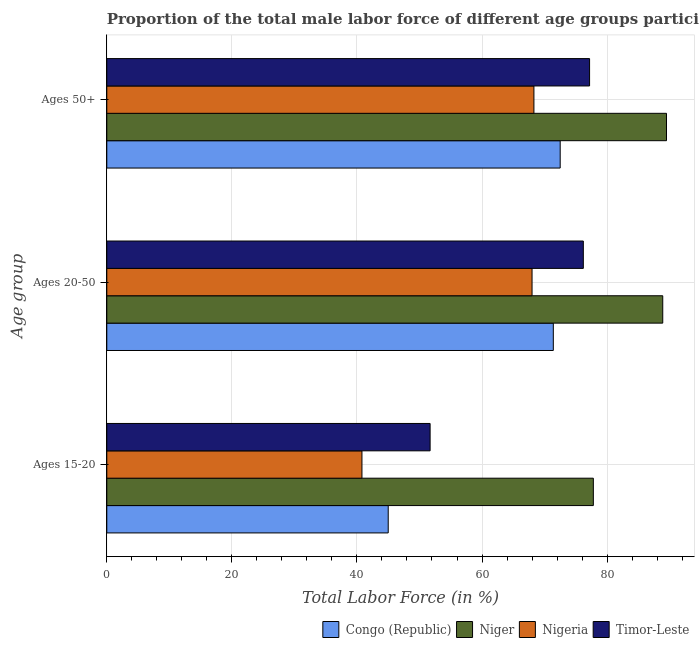How many groups of bars are there?
Your response must be concise. 3. What is the label of the 2nd group of bars from the top?
Offer a terse response. Ages 20-50. What is the percentage of male labor force within the age group 20-50 in Timor-Leste?
Your response must be concise. 76.2. Across all countries, what is the maximum percentage of male labor force above age 50?
Offer a terse response. 89.5. In which country was the percentage of male labor force above age 50 maximum?
Offer a very short reply. Niger. In which country was the percentage of male labor force above age 50 minimum?
Provide a succinct answer. Nigeria. What is the total percentage of male labor force within the age group 15-20 in the graph?
Provide a short and direct response. 215.3. What is the difference between the percentage of male labor force within the age group 20-50 in Niger and that in Nigeria?
Give a very brief answer. 20.9. What is the difference between the percentage of male labor force within the age group 20-50 in Timor-Leste and the percentage of male labor force within the age group 15-20 in Congo (Republic)?
Provide a short and direct response. 31.2. What is the average percentage of male labor force within the age group 15-20 per country?
Your response must be concise. 53.83. What is the difference between the percentage of male labor force above age 50 and percentage of male labor force within the age group 15-20 in Nigeria?
Make the answer very short. 27.5. In how many countries, is the percentage of male labor force within the age group 15-20 greater than 24 %?
Your response must be concise. 4. What is the ratio of the percentage of male labor force within the age group 20-50 in Congo (Republic) to that in Niger?
Make the answer very short. 0.8. Is the percentage of male labor force within the age group 15-20 in Niger less than that in Congo (Republic)?
Offer a very short reply. No. What is the difference between the highest and the second highest percentage of male labor force within the age group 15-20?
Your answer should be compact. 26.1. What is the difference between the highest and the lowest percentage of male labor force within the age group 15-20?
Provide a short and direct response. 37. In how many countries, is the percentage of male labor force within the age group 15-20 greater than the average percentage of male labor force within the age group 15-20 taken over all countries?
Provide a short and direct response. 1. Is the sum of the percentage of male labor force within the age group 15-20 in Timor-Leste and Niger greater than the maximum percentage of male labor force within the age group 20-50 across all countries?
Keep it short and to the point. Yes. What does the 1st bar from the top in Ages 15-20 represents?
Make the answer very short. Timor-Leste. What does the 3rd bar from the bottom in Ages 15-20 represents?
Provide a succinct answer. Nigeria. Is it the case that in every country, the sum of the percentage of male labor force within the age group 15-20 and percentage of male labor force within the age group 20-50 is greater than the percentage of male labor force above age 50?
Your response must be concise. Yes. How many countries are there in the graph?
Provide a succinct answer. 4. What is the difference between two consecutive major ticks on the X-axis?
Offer a terse response. 20. Are the values on the major ticks of X-axis written in scientific E-notation?
Your response must be concise. No. Does the graph contain any zero values?
Ensure brevity in your answer.  No. Does the graph contain grids?
Provide a short and direct response. Yes. How many legend labels are there?
Make the answer very short. 4. What is the title of the graph?
Give a very brief answer. Proportion of the total male labor force of different age groups participating in production in 1999. Does "Puerto Rico" appear as one of the legend labels in the graph?
Your answer should be very brief. No. What is the label or title of the Y-axis?
Your answer should be very brief. Age group. What is the Total Labor Force (in %) in Niger in Ages 15-20?
Keep it short and to the point. 77.8. What is the Total Labor Force (in %) in Nigeria in Ages 15-20?
Make the answer very short. 40.8. What is the Total Labor Force (in %) in Timor-Leste in Ages 15-20?
Your response must be concise. 51.7. What is the Total Labor Force (in %) in Congo (Republic) in Ages 20-50?
Ensure brevity in your answer.  71.4. What is the Total Labor Force (in %) in Niger in Ages 20-50?
Offer a very short reply. 88.9. What is the Total Labor Force (in %) in Timor-Leste in Ages 20-50?
Your response must be concise. 76.2. What is the Total Labor Force (in %) of Congo (Republic) in Ages 50+?
Your answer should be very brief. 72.5. What is the Total Labor Force (in %) of Niger in Ages 50+?
Your answer should be very brief. 89.5. What is the Total Labor Force (in %) of Nigeria in Ages 50+?
Keep it short and to the point. 68.3. What is the Total Labor Force (in %) in Timor-Leste in Ages 50+?
Provide a short and direct response. 77.2. Across all Age group, what is the maximum Total Labor Force (in %) in Congo (Republic)?
Offer a very short reply. 72.5. Across all Age group, what is the maximum Total Labor Force (in %) in Niger?
Keep it short and to the point. 89.5. Across all Age group, what is the maximum Total Labor Force (in %) of Nigeria?
Offer a terse response. 68.3. Across all Age group, what is the maximum Total Labor Force (in %) in Timor-Leste?
Make the answer very short. 77.2. Across all Age group, what is the minimum Total Labor Force (in %) in Niger?
Keep it short and to the point. 77.8. Across all Age group, what is the minimum Total Labor Force (in %) of Nigeria?
Provide a short and direct response. 40.8. Across all Age group, what is the minimum Total Labor Force (in %) of Timor-Leste?
Your answer should be very brief. 51.7. What is the total Total Labor Force (in %) in Congo (Republic) in the graph?
Make the answer very short. 188.9. What is the total Total Labor Force (in %) in Niger in the graph?
Give a very brief answer. 256.2. What is the total Total Labor Force (in %) in Nigeria in the graph?
Provide a succinct answer. 177.1. What is the total Total Labor Force (in %) in Timor-Leste in the graph?
Your answer should be compact. 205.1. What is the difference between the Total Labor Force (in %) of Congo (Republic) in Ages 15-20 and that in Ages 20-50?
Your answer should be very brief. -26.4. What is the difference between the Total Labor Force (in %) of Nigeria in Ages 15-20 and that in Ages 20-50?
Keep it short and to the point. -27.2. What is the difference between the Total Labor Force (in %) of Timor-Leste in Ages 15-20 and that in Ages 20-50?
Make the answer very short. -24.5. What is the difference between the Total Labor Force (in %) in Congo (Republic) in Ages 15-20 and that in Ages 50+?
Provide a short and direct response. -27.5. What is the difference between the Total Labor Force (in %) in Niger in Ages 15-20 and that in Ages 50+?
Offer a very short reply. -11.7. What is the difference between the Total Labor Force (in %) of Nigeria in Ages 15-20 and that in Ages 50+?
Your response must be concise. -27.5. What is the difference between the Total Labor Force (in %) in Timor-Leste in Ages 15-20 and that in Ages 50+?
Your answer should be compact. -25.5. What is the difference between the Total Labor Force (in %) of Nigeria in Ages 20-50 and that in Ages 50+?
Ensure brevity in your answer.  -0.3. What is the difference between the Total Labor Force (in %) in Congo (Republic) in Ages 15-20 and the Total Labor Force (in %) in Niger in Ages 20-50?
Your response must be concise. -43.9. What is the difference between the Total Labor Force (in %) in Congo (Republic) in Ages 15-20 and the Total Labor Force (in %) in Timor-Leste in Ages 20-50?
Make the answer very short. -31.2. What is the difference between the Total Labor Force (in %) of Nigeria in Ages 15-20 and the Total Labor Force (in %) of Timor-Leste in Ages 20-50?
Your answer should be very brief. -35.4. What is the difference between the Total Labor Force (in %) of Congo (Republic) in Ages 15-20 and the Total Labor Force (in %) of Niger in Ages 50+?
Give a very brief answer. -44.5. What is the difference between the Total Labor Force (in %) of Congo (Republic) in Ages 15-20 and the Total Labor Force (in %) of Nigeria in Ages 50+?
Your answer should be compact. -23.3. What is the difference between the Total Labor Force (in %) in Congo (Republic) in Ages 15-20 and the Total Labor Force (in %) in Timor-Leste in Ages 50+?
Your answer should be very brief. -32.2. What is the difference between the Total Labor Force (in %) in Niger in Ages 15-20 and the Total Labor Force (in %) in Timor-Leste in Ages 50+?
Provide a succinct answer. 0.6. What is the difference between the Total Labor Force (in %) in Nigeria in Ages 15-20 and the Total Labor Force (in %) in Timor-Leste in Ages 50+?
Provide a short and direct response. -36.4. What is the difference between the Total Labor Force (in %) of Congo (Republic) in Ages 20-50 and the Total Labor Force (in %) of Niger in Ages 50+?
Provide a succinct answer. -18.1. What is the difference between the Total Labor Force (in %) of Niger in Ages 20-50 and the Total Labor Force (in %) of Nigeria in Ages 50+?
Offer a very short reply. 20.6. What is the difference between the Total Labor Force (in %) of Niger in Ages 20-50 and the Total Labor Force (in %) of Timor-Leste in Ages 50+?
Your answer should be very brief. 11.7. What is the average Total Labor Force (in %) of Congo (Republic) per Age group?
Your answer should be very brief. 62.97. What is the average Total Labor Force (in %) of Niger per Age group?
Your answer should be very brief. 85.4. What is the average Total Labor Force (in %) of Nigeria per Age group?
Your answer should be very brief. 59.03. What is the average Total Labor Force (in %) in Timor-Leste per Age group?
Your answer should be compact. 68.37. What is the difference between the Total Labor Force (in %) in Congo (Republic) and Total Labor Force (in %) in Niger in Ages 15-20?
Your answer should be compact. -32.8. What is the difference between the Total Labor Force (in %) of Congo (Republic) and Total Labor Force (in %) of Timor-Leste in Ages 15-20?
Your answer should be very brief. -6.7. What is the difference between the Total Labor Force (in %) of Niger and Total Labor Force (in %) of Timor-Leste in Ages 15-20?
Offer a very short reply. 26.1. What is the difference between the Total Labor Force (in %) in Congo (Republic) and Total Labor Force (in %) in Niger in Ages 20-50?
Offer a terse response. -17.5. What is the difference between the Total Labor Force (in %) in Niger and Total Labor Force (in %) in Nigeria in Ages 20-50?
Give a very brief answer. 20.9. What is the difference between the Total Labor Force (in %) of Nigeria and Total Labor Force (in %) of Timor-Leste in Ages 20-50?
Make the answer very short. -8.2. What is the difference between the Total Labor Force (in %) of Congo (Republic) and Total Labor Force (in %) of Timor-Leste in Ages 50+?
Your response must be concise. -4.7. What is the difference between the Total Labor Force (in %) of Niger and Total Labor Force (in %) of Nigeria in Ages 50+?
Provide a succinct answer. 21.2. What is the difference between the Total Labor Force (in %) in Niger and Total Labor Force (in %) in Timor-Leste in Ages 50+?
Ensure brevity in your answer.  12.3. What is the ratio of the Total Labor Force (in %) of Congo (Republic) in Ages 15-20 to that in Ages 20-50?
Make the answer very short. 0.63. What is the ratio of the Total Labor Force (in %) in Niger in Ages 15-20 to that in Ages 20-50?
Offer a very short reply. 0.88. What is the ratio of the Total Labor Force (in %) of Timor-Leste in Ages 15-20 to that in Ages 20-50?
Offer a terse response. 0.68. What is the ratio of the Total Labor Force (in %) of Congo (Republic) in Ages 15-20 to that in Ages 50+?
Offer a very short reply. 0.62. What is the ratio of the Total Labor Force (in %) of Niger in Ages 15-20 to that in Ages 50+?
Provide a succinct answer. 0.87. What is the ratio of the Total Labor Force (in %) in Nigeria in Ages 15-20 to that in Ages 50+?
Your answer should be very brief. 0.6. What is the ratio of the Total Labor Force (in %) of Timor-Leste in Ages 15-20 to that in Ages 50+?
Ensure brevity in your answer.  0.67. What is the ratio of the Total Labor Force (in %) in Niger in Ages 20-50 to that in Ages 50+?
Provide a short and direct response. 0.99. What is the ratio of the Total Labor Force (in %) in Nigeria in Ages 20-50 to that in Ages 50+?
Make the answer very short. 1. What is the ratio of the Total Labor Force (in %) of Timor-Leste in Ages 20-50 to that in Ages 50+?
Make the answer very short. 0.99. What is the difference between the highest and the lowest Total Labor Force (in %) of Niger?
Keep it short and to the point. 11.7. What is the difference between the highest and the lowest Total Labor Force (in %) in Nigeria?
Make the answer very short. 27.5. 